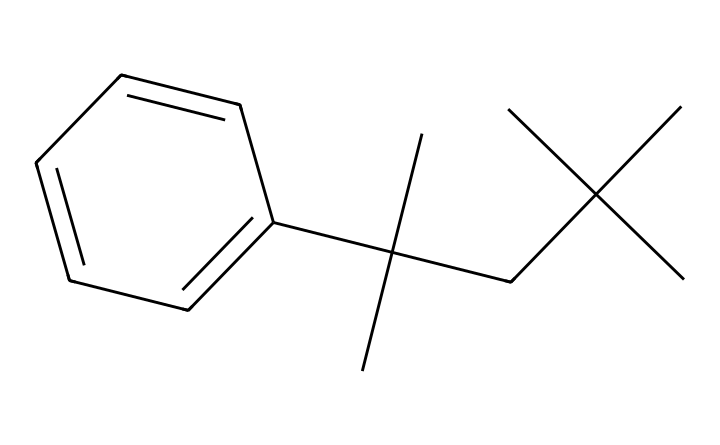What is the molecular formula for this compound? The SMILES representation contains several carbon (C) and hydrogen (H) atoms. By analyzing the structure, we can count the carbons and deduce the number of hydrogens based on typical valences. There are 15 carbons and 24 hydrogens, making the molecular formula C15H24.
Answer: C15H24 How many rings does the structure have? By inspecting the SMILES notation, it can be seen that the chemical includes a cyclic structure indicated by the presence of "C1...C1," which shows one ring.
Answer: 1 What type of plastic is represented here? Given that the SMILES correlates to polystyrene, which is a polymerized version of styrene, this structure indicates that it is a thermoplastic widely used in foam cups.
Answer: thermoplastic How many double bonds are present in the compound? The structure reveals that there is only one double bond present between two carbons, indicated by the "C=C" in the chemical.
Answer: 1 What is the overall shape of the molecules suggested by this structure? The presence of branches and a ring suggests that the overall molecular shape will be more complex and possibly spherical or globular, which is typical for many plastics.
Answer: globular 